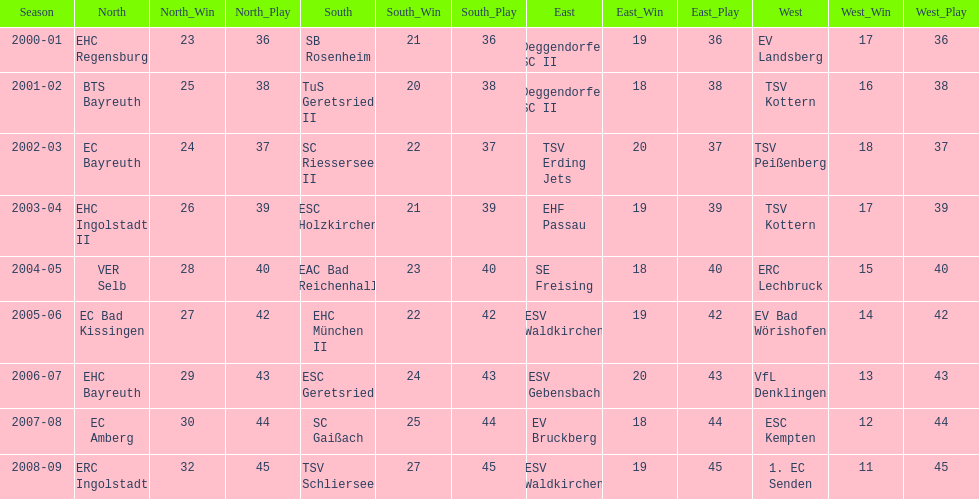How many champions are listend in the north? 9. 